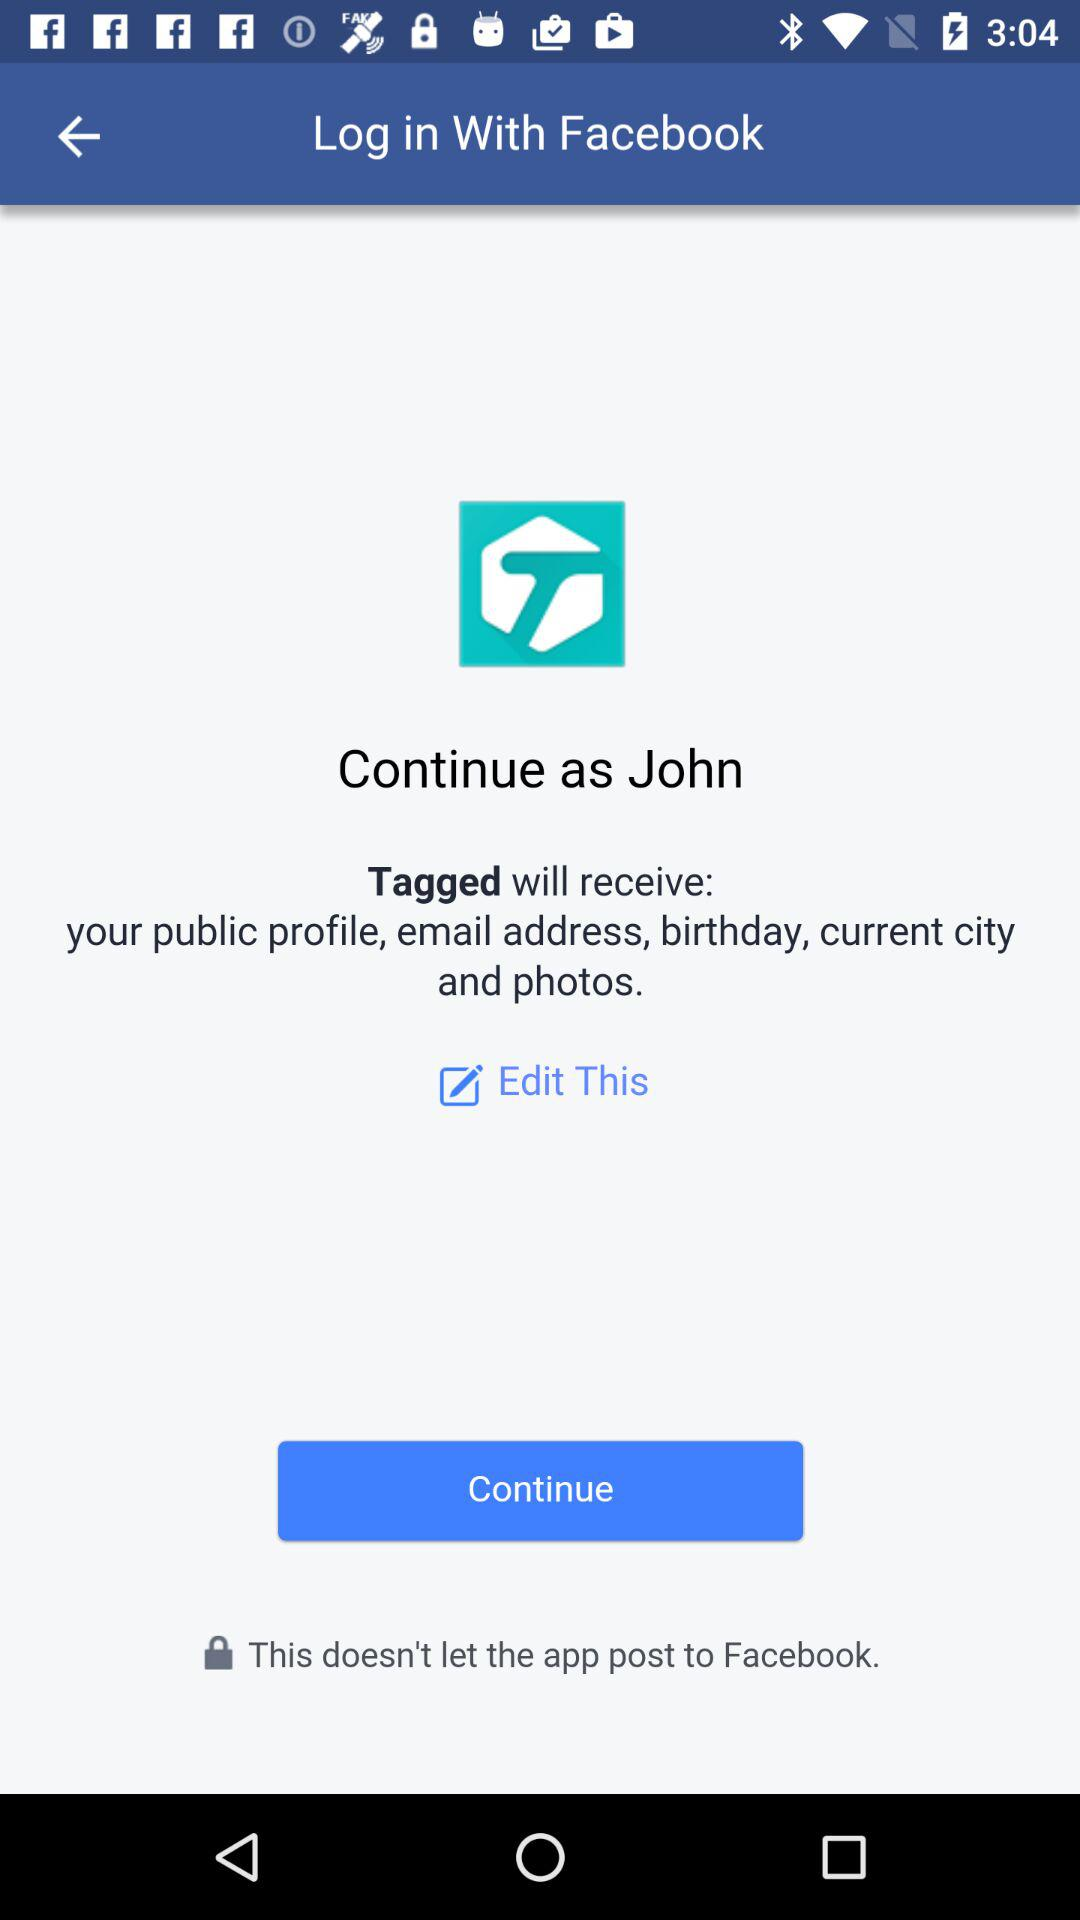When was "Tagged" updated?
When the provided information is insufficient, respond with <no answer>. <no answer> 